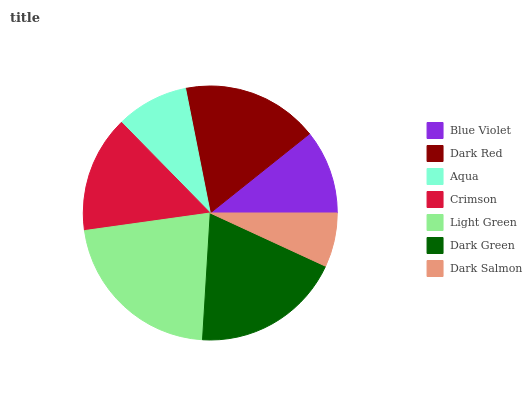Is Dark Salmon the minimum?
Answer yes or no. Yes. Is Light Green the maximum?
Answer yes or no. Yes. Is Dark Red the minimum?
Answer yes or no. No. Is Dark Red the maximum?
Answer yes or no. No. Is Dark Red greater than Blue Violet?
Answer yes or no. Yes. Is Blue Violet less than Dark Red?
Answer yes or no. Yes. Is Blue Violet greater than Dark Red?
Answer yes or no. No. Is Dark Red less than Blue Violet?
Answer yes or no. No. Is Crimson the high median?
Answer yes or no. Yes. Is Crimson the low median?
Answer yes or no. Yes. Is Dark Green the high median?
Answer yes or no. No. Is Light Green the low median?
Answer yes or no. No. 